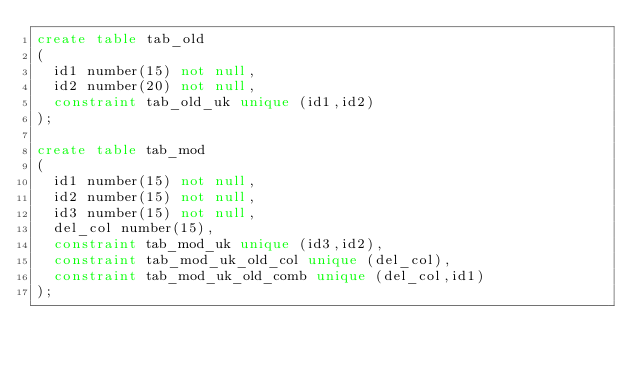Convert code to text. <code><loc_0><loc_0><loc_500><loc_500><_SQL_>create table tab_old
(
  id1 number(15) not null,
  id2 number(20) not null,
  constraint tab_old_uk unique (id1,id2)
);

create table tab_mod
(
  id1 number(15) not null,
  id2 number(15) not null,
  id3 number(15) not null,
  del_col number(15),
  constraint tab_mod_uk unique (id3,id2),
  constraint tab_mod_uk_old_col unique (del_col),
  constraint tab_mod_uk_old_comb unique (del_col,id1)
);


</code> 